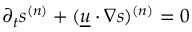Convert formula to latex. <formula><loc_0><loc_0><loc_500><loc_500>\partial _ { t } { s ^ { ( n ) } } + { ( \underline { u } { \cdot } \nabla s ) ^ { ( n ) } } = 0</formula> 